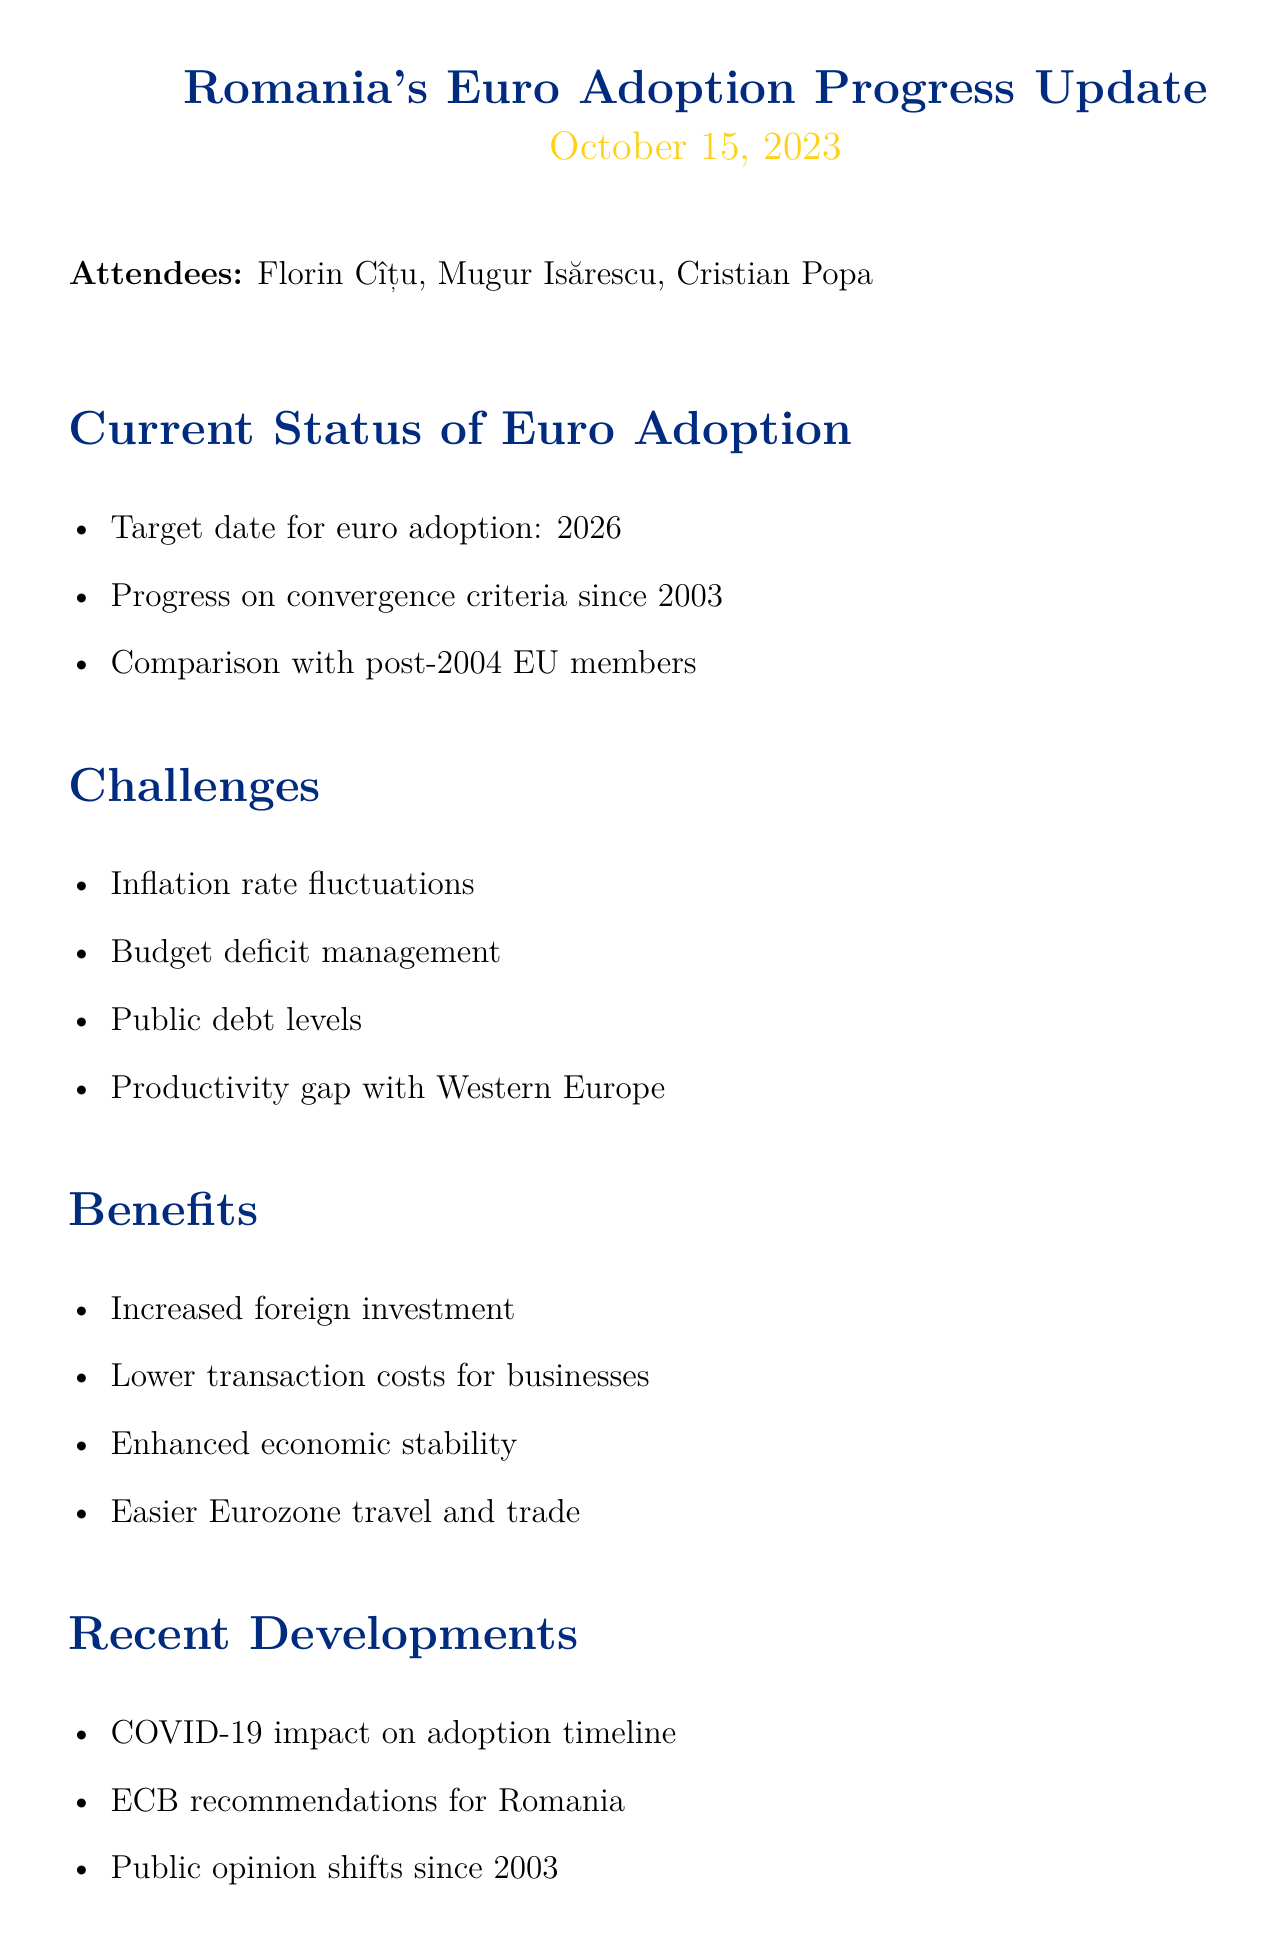What is Romania's target date for euro adoption? The document states that Romania's target date for euro adoption is 2026.
Answer: 2026 Who is the Governor of the National Bank of Romania? The document lists Mugur Isărescu as the Governor of the National Bank of Romania.
Answer: Mugur Isărescu What are the challenges mentioned for Romania's euro adoption? The document lists several challenges including inflation fluctuations, budget deficit management, public debt levels, and productivity gap.
Answer: Inflation rate fluctuations, budget deficit management, public debt levels, productivity gap with Western European countries What is one benefit of euro adoption mentioned? The document specifies that one benefit is increased foreign investment.
Answer: Increased foreign investment What recent event impacted the timeline for euro adoption? The document notes the impact of the COVID-19 pandemic on the euro adoption timeline.
Answer: COVID-19 pandemic What is one of the next steps for Romania's euro adoption? The document mentions strengthening fiscal policies as one of the next steps.
Answer: Strengthening fiscal policies When was this meeting held? The date of the meeting is stated in the document as October 15, 2023.
Answer: October 15, 2023 Who attended the meeting? The document lists Florin Cîțu, Mugur Isărescu, and Cristian Popa as attendees.
Answer: Florin Cîțu, Mugur Isărescu, Cristian Popa What is the significance of public opinion shifts since 2003? The document indicates that public opinion shifts are relevant to understanding the progress in euro adoption.
Answer: Public opinion shifts since 2003 